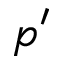Convert formula to latex. <formula><loc_0><loc_0><loc_500><loc_500>p ^ { \prime }</formula> 